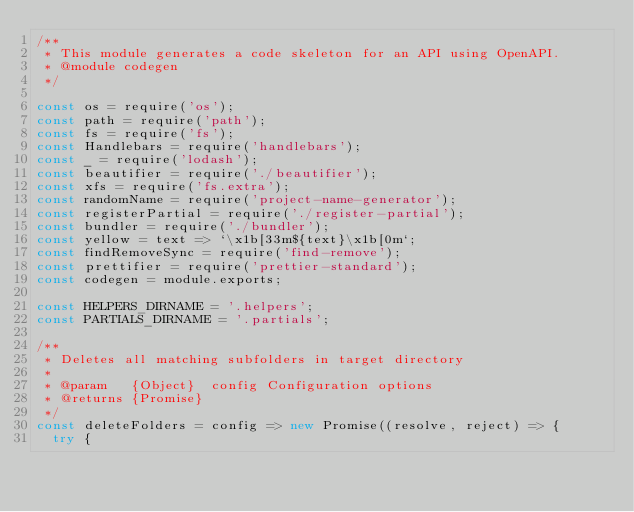Convert code to text. <code><loc_0><loc_0><loc_500><loc_500><_JavaScript_>/**
 * This module generates a code skeleton for an API using OpenAPI.
 * @module codegen
 */

const os = require('os');
const path = require('path');
const fs = require('fs');
const Handlebars = require('handlebars');
const _ = require('lodash');
const beautifier = require('./beautifier');
const xfs = require('fs.extra');
const randomName = require('project-name-generator');
const registerPartial = require('./register-partial');
const bundler = require('./bundler');
const yellow = text => `\x1b[33m${text}\x1b[0m`;
const findRemoveSync = require('find-remove');
const prettifier = require('prettier-standard');
const codegen = module.exports;

const HELPERS_DIRNAME = '.helpers';
const PARTIALS_DIRNAME = '.partials';

/**
 * Deletes all matching subfolders in target directory
 *
 * @param   {Object}  config Configuration options
 * @returns {Promise}
 */
const deleteFolders = config => new Promise((resolve, reject) => {
  try {</code> 